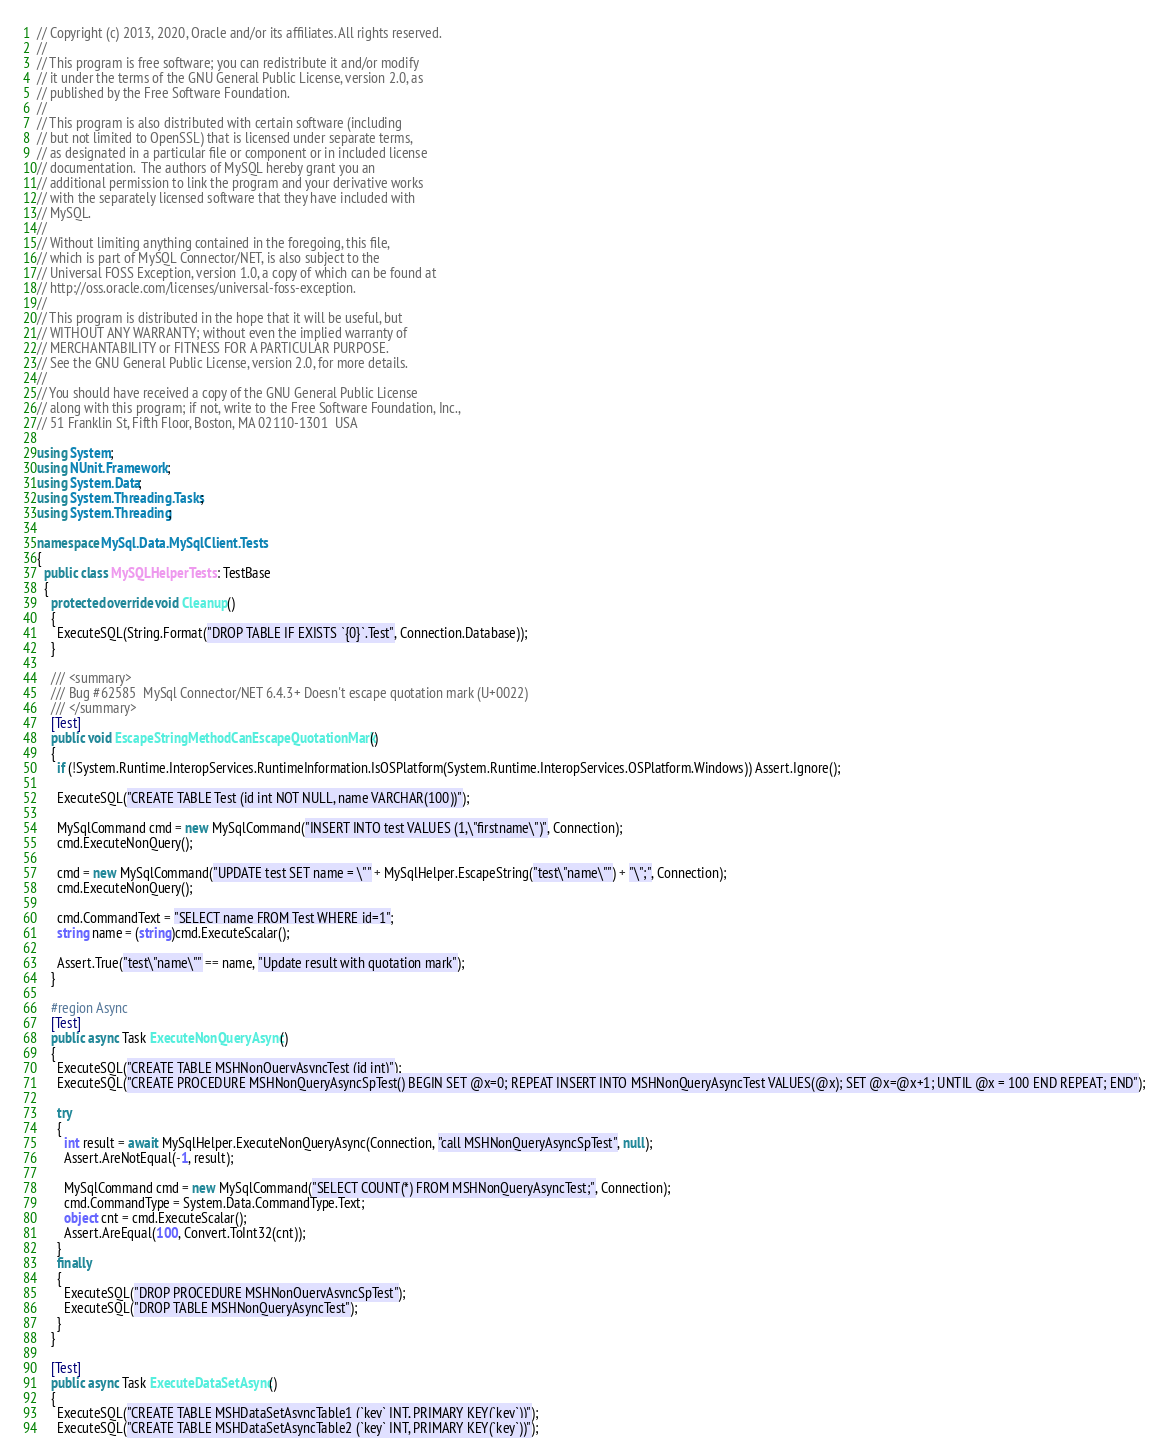<code> <loc_0><loc_0><loc_500><loc_500><_C#_>// Copyright (c) 2013, 2020, Oracle and/or its affiliates. All rights reserved.
//
// This program is free software; you can redistribute it and/or modify
// it under the terms of the GNU General Public License, version 2.0, as
// published by the Free Software Foundation.
//
// This program is also distributed with certain software (including
// but not limited to OpenSSL) that is licensed under separate terms,
// as designated in a particular file or component or in included license
// documentation.  The authors of MySQL hereby grant you an
// additional permission to link the program and your derivative works
// with the separately licensed software that they have included with
// MySQL.
//
// Without limiting anything contained in the foregoing, this file,
// which is part of MySQL Connector/NET, is also subject to the
// Universal FOSS Exception, version 1.0, a copy of which can be found at
// http://oss.oracle.com/licenses/universal-foss-exception.
//
// This program is distributed in the hope that it will be useful, but
// WITHOUT ANY WARRANTY; without even the implied warranty of
// MERCHANTABILITY or FITNESS FOR A PARTICULAR PURPOSE.
// See the GNU General Public License, version 2.0, for more details.
//
// You should have received a copy of the GNU General Public License
// along with this program; if not, write to the Free Software Foundation, Inc.,
// 51 Franklin St, Fifth Floor, Boston, MA 02110-1301  USA

using System;
using NUnit.Framework;
using System.Data;
using System.Threading.Tasks;
using System.Threading;

namespace MySql.Data.MySqlClient.Tests
{
  public class MySQLHelperTests : TestBase
  {
    protected override void Cleanup()
    {
      ExecuteSQL(String.Format("DROP TABLE IF EXISTS `{0}`.Test", Connection.Database));
    }

    /// <summary>
    /// Bug #62585	MySql Connector/NET 6.4.3+ Doesn't escape quotation mark (U+0022)
    /// </summary>
    [Test]
    public void EscapeStringMethodCanEscapeQuotationMark()
    {
      if (!System.Runtime.InteropServices.RuntimeInformation.IsOSPlatform(System.Runtime.InteropServices.OSPlatform.Windows)) Assert.Ignore();

      ExecuteSQL("CREATE TABLE Test (id int NOT NULL, name VARCHAR(100))");

      MySqlCommand cmd = new MySqlCommand("INSERT INTO test VALUES (1,\"firstname\")", Connection);
      cmd.ExecuteNonQuery();

      cmd = new MySqlCommand("UPDATE test SET name = \"" + MySqlHelper.EscapeString("test\"name\"") + "\";", Connection);
      cmd.ExecuteNonQuery();

      cmd.CommandText = "SELECT name FROM Test WHERE id=1";
      string name = (string)cmd.ExecuteScalar();

      Assert.True("test\"name\"" == name, "Update result with quotation mark");
    }

    #region Async
    [Test]
    public async Task ExecuteNonQueryAsync()
    {
      ExecuteSQL("CREATE TABLE MSHNonQueryAsyncTest (id int)");
      ExecuteSQL("CREATE PROCEDURE MSHNonQueryAsyncSpTest() BEGIN SET @x=0; REPEAT INSERT INTO MSHNonQueryAsyncTest VALUES(@x); SET @x=@x+1; UNTIL @x = 100 END REPEAT; END");

      try
      {
        int result = await MySqlHelper.ExecuteNonQueryAsync(Connection, "call MSHNonQueryAsyncSpTest", null);
        Assert.AreNotEqual(-1, result);

        MySqlCommand cmd = new MySqlCommand("SELECT COUNT(*) FROM MSHNonQueryAsyncTest;", Connection);
        cmd.CommandType = System.Data.CommandType.Text;
        object cnt = cmd.ExecuteScalar();
        Assert.AreEqual(100, Convert.ToInt32(cnt));
      }
      finally
      {
        ExecuteSQL("DROP PROCEDURE MSHNonQueryAsyncSpTest");
        ExecuteSQL("DROP TABLE MSHNonQueryAsyncTest");
      }
    }

    [Test]
    public async Task ExecuteDataSetAsync()
    {
      ExecuteSQL("CREATE TABLE MSHDataSetAsyncTable1 (`key` INT, PRIMARY KEY(`key`))");
      ExecuteSQL("CREATE TABLE MSHDataSetAsyncTable2 (`key` INT, PRIMARY KEY(`key`))");</code> 